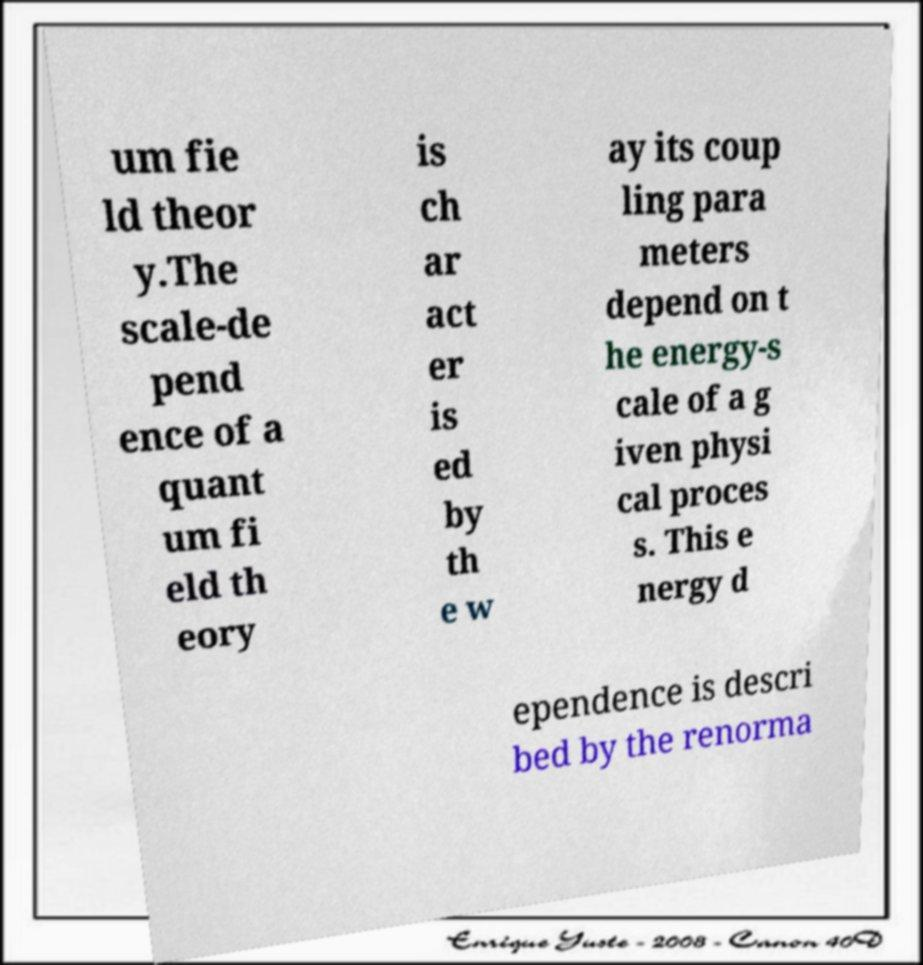Can you accurately transcribe the text from the provided image for me? um fie ld theor y.The scale-de pend ence of a quant um fi eld th eory is ch ar act er is ed by th e w ay its coup ling para meters depend on t he energy-s cale of a g iven physi cal proces s. This e nergy d ependence is descri bed by the renorma 